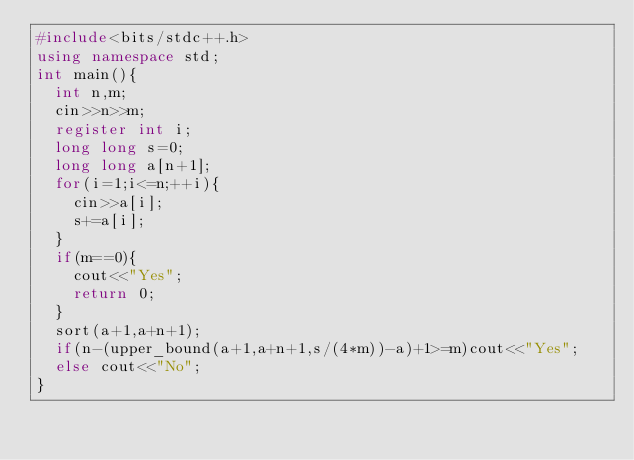<code> <loc_0><loc_0><loc_500><loc_500><_C++_>#include<bits/stdc++.h>
using namespace std;
int main(){
	int n,m;
	cin>>n>>m;
	register int i;
	long long s=0;
	long long a[n+1];
	for(i=1;i<=n;++i){
		cin>>a[i];
		s+=a[i];
	}
	if(m==0){
		cout<<"Yes";
		return 0;
	}
	sort(a+1,a+n+1);
	if(n-(upper_bound(a+1,a+n+1,s/(4*m))-a)+1>=m)cout<<"Yes";
	else cout<<"No";
}</code> 